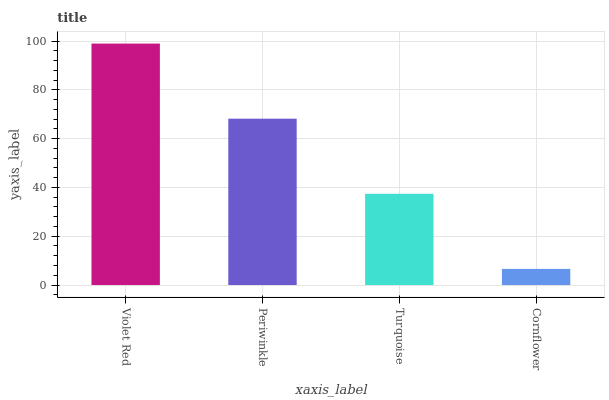Is Periwinkle the minimum?
Answer yes or no. No. Is Periwinkle the maximum?
Answer yes or no. No. Is Violet Red greater than Periwinkle?
Answer yes or no. Yes. Is Periwinkle less than Violet Red?
Answer yes or no. Yes. Is Periwinkle greater than Violet Red?
Answer yes or no. No. Is Violet Red less than Periwinkle?
Answer yes or no. No. Is Periwinkle the high median?
Answer yes or no. Yes. Is Turquoise the low median?
Answer yes or no. Yes. Is Cornflower the high median?
Answer yes or no. No. Is Violet Red the low median?
Answer yes or no. No. 